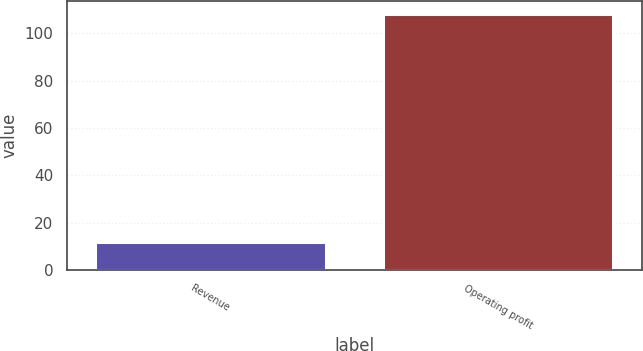<chart> <loc_0><loc_0><loc_500><loc_500><bar_chart><fcel>Revenue<fcel>Operating profit<nl><fcel>12<fcel>108<nl></chart> 